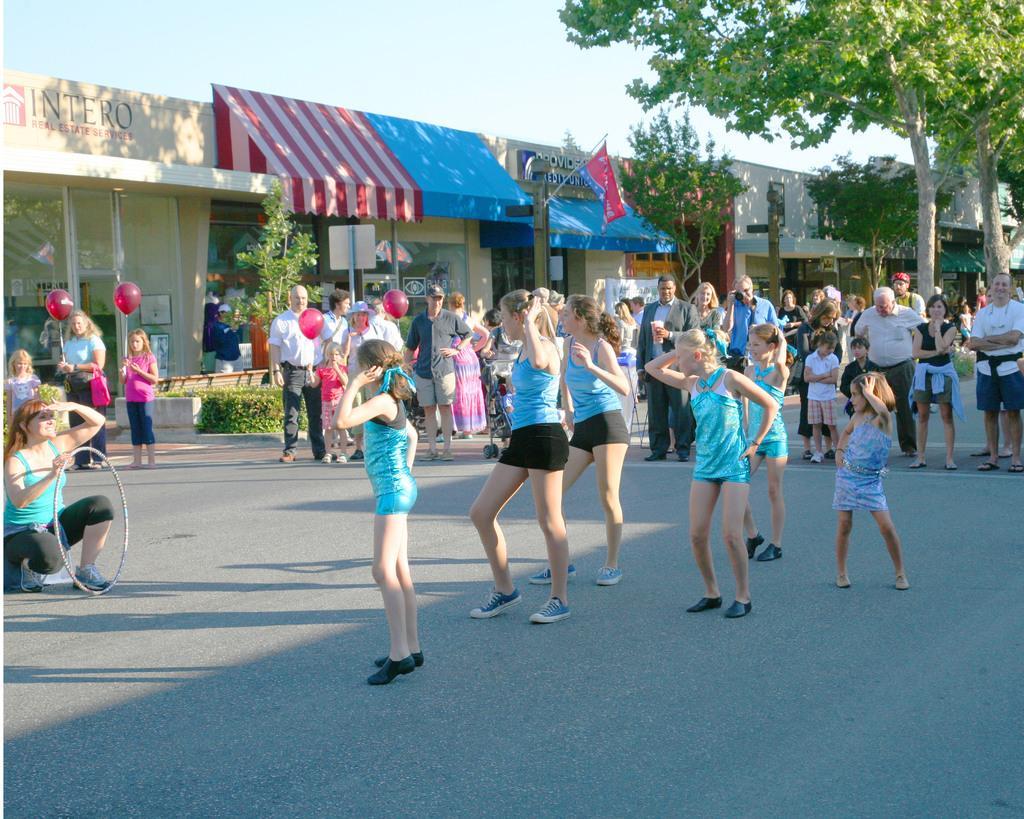Could you give a brief overview of what you see in this image? In this image there are group of persons who are standing, in the foreground there are some persons who are doing some dance. In the background there are some buildings, trees, tents, flag and some plants. At the bottom there is road, and on the left side there is one woman who is sitting and she is holding one tray. At the top of the image there is sky. 